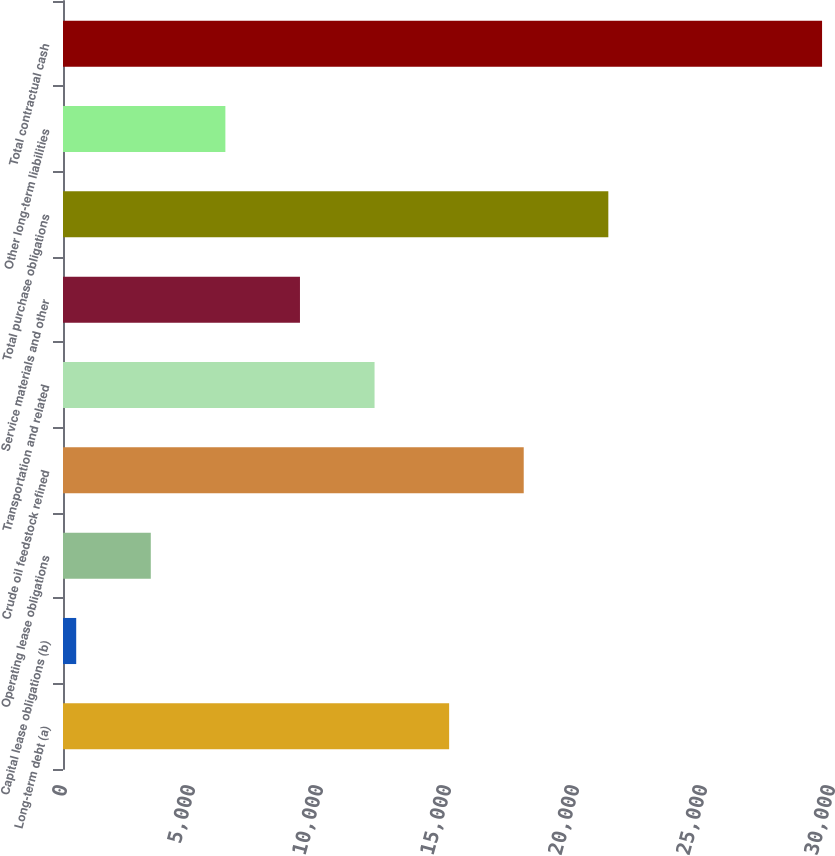<chart> <loc_0><loc_0><loc_500><loc_500><bar_chart><fcel>Long-term debt (a)<fcel>Capital lease obligations (b)<fcel>Operating lease obligations<fcel>Crude oil feedstock refined<fcel>Transportation and related<fcel>Service materials and other<fcel>Total purchase obligations<fcel>Other long-term liabilities<fcel>Total contractual cash<nl><fcel>15083.5<fcel>516<fcel>3429.5<fcel>17997<fcel>12170<fcel>9256.5<fcel>21302<fcel>6343<fcel>29651<nl></chart> 